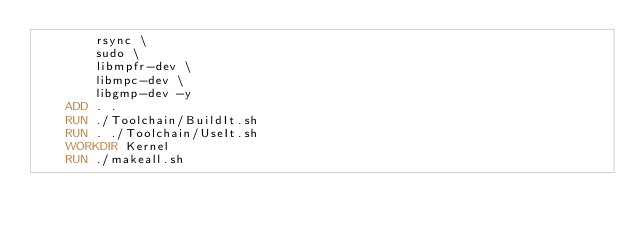<code> <loc_0><loc_0><loc_500><loc_500><_Dockerfile_>        rsync \
        sudo \
        libmpfr-dev \
        libmpc-dev \
        libgmp-dev -y
    ADD . .
    RUN ./Toolchain/BuildIt.sh
    RUN . ./Toolchain/UseIt.sh
    WORKDIR Kernel
    RUN ./makeall.sh </code> 